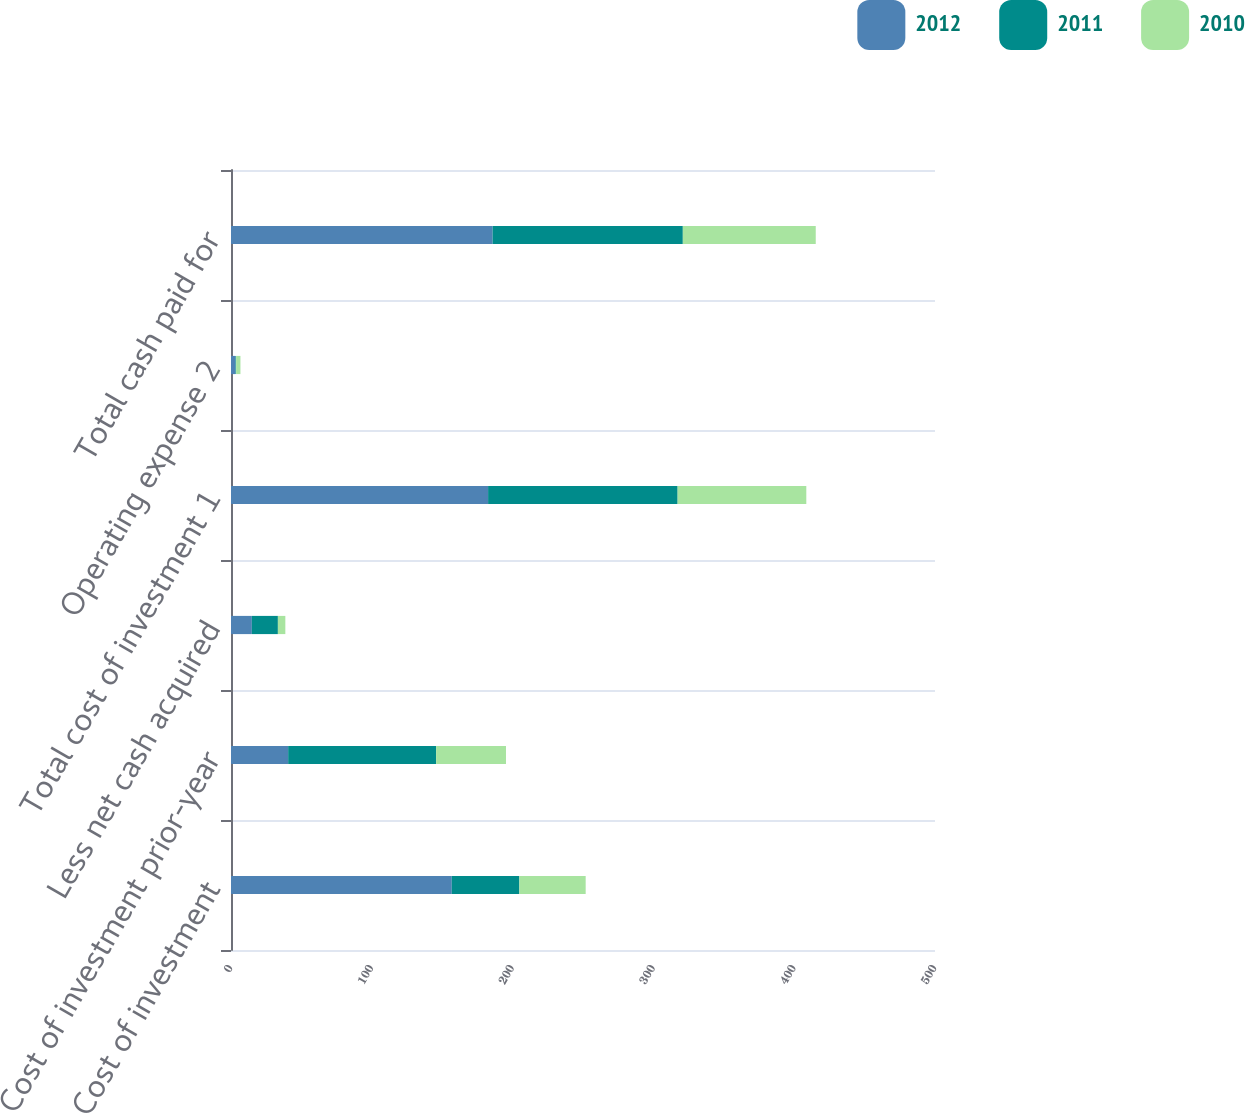Convert chart to OTSL. <chart><loc_0><loc_0><loc_500><loc_500><stacked_bar_chart><ecel><fcel>Cost of investment<fcel>Cost of investment prior-year<fcel>Less net cash acquired<fcel>Total cost of investment 1<fcel>Operating expense 2<fcel>Total cash paid for<nl><fcel>2012<fcel>156.8<fcel>40.6<fcel>14.8<fcel>182.6<fcel>3.2<fcel>185.8<nl><fcel>2011<fcel>48<fcel>105.1<fcel>18.5<fcel>134.6<fcel>0.5<fcel>135.1<nl><fcel>2010<fcel>47.1<fcel>49.6<fcel>5.3<fcel>91.4<fcel>3<fcel>94.4<nl></chart> 